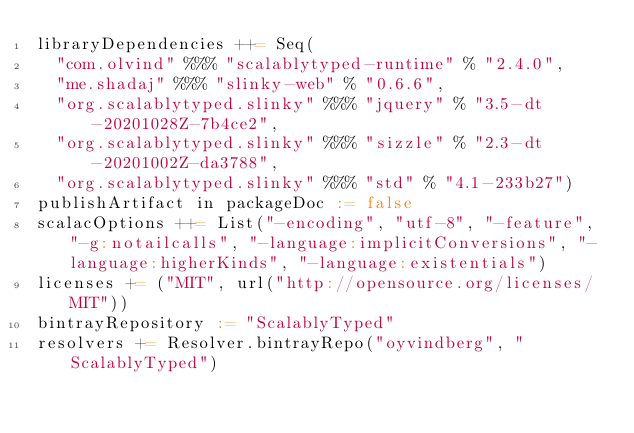<code> <loc_0><loc_0><loc_500><loc_500><_Scala_>libraryDependencies ++= Seq(
  "com.olvind" %%% "scalablytyped-runtime" % "2.4.0",
  "me.shadaj" %%% "slinky-web" % "0.6.6",
  "org.scalablytyped.slinky" %%% "jquery" % "3.5-dt-20201028Z-7b4ce2",
  "org.scalablytyped.slinky" %%% "sizzle" % "2.3-dt-20201002Z-da3788",
  "org.scalablytyped.slinky" %%% "std" % "4.1-233b27")
publishArtifact in packageDoc := false
scalacOptions ++= List("-encoding", "utf-8", "-feature", "-g:notailcalls", "-language:implicitConversions", "-language:higherKinds", "-language:existentials")
licenses += ("MIT", url("http://opensource.org/licenses/MIT"))
bintrayRepository := "ScalablyTyped"
resolvers += Resolver.bintrayRepo("oyvindberg", "ScalablyTyped")
</code> 